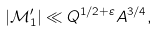<formula> <loc_0><loc_0><loc_500><loc_500>| \mathcal { M } _ { 1 } ^ { \prime } | \ll Q ^ { 1 / 2 + \varepsilon } A ^ { 3 / 4 } ,</formula> 